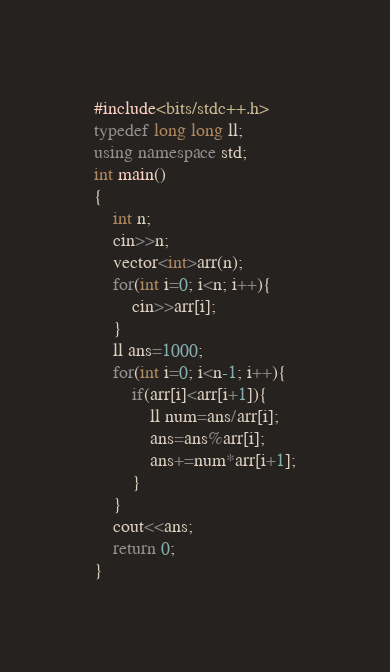<code> <loc_0><loc_0><loc_500><loc_500><_C++_>#include<bits/stdc++.h>
typedef long long ll;
using namespace std;
int main()
{
	int n;
	cin>>n;
	vector<int>arr(n);
	for(int i=0; i<n; i++){
		cin>>arr[i];
	}
	ll ans=1000;
	for(int i=0; i<n-1; i++){
		if(arr[i]<arr[i+1]){
			ll num=ans/arr[i];
			ans=ans%arr[i];
			ans+=num*arr[i+1];
		}
	}
	cout<<ans;
	return 0;
}</code> 